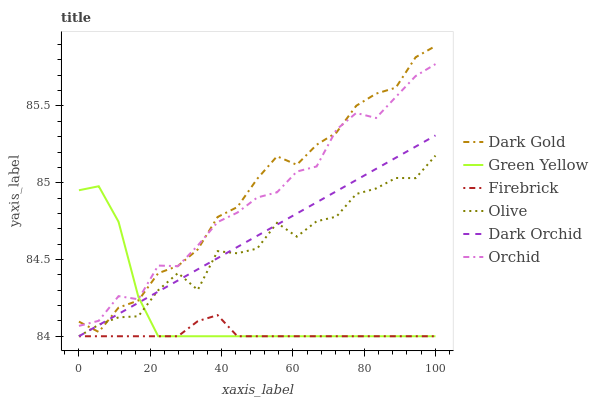Does Firebrick have the minimum area under the curve?
Answer yes or no. Yes. Does Dark Gold have the maximum area under the curve?
Answer yes or no. Yes. Does Dark Orchid have the minimum area under the curve?
Answer yes or no. No. Does Dark Orchid have the maximum area under the curve?
Answer yes or no. No. Is Dark Orchid the smoothest?
Answer yes or no. Yes. Is Olive the roughest?
Answer yes or no. Yes. Is Firebrick the smoothest?
Answer yes or no. No. Is Firebrick the roughest?
Answer yes or no. No. Does Firebrick have the lowest value?
Answer yes or no. Yes. Does Orchid have the lowest value?
Answer yes or no. No. Does Dark Gold have the highest value?
Answer yes or no. Yes. Does Dark Orchid have the highest value?
Answer yes or no. No. Is Dark Orchid less than Orchid?
Answer yes or no. Yes. Is Orchid greater than Olive?
Answer yes or no. Yes. Does Dark Gold intersect Olive?
Answer yes or no. Yes. Is Dark Gold less than Olive?
Answer yes or no. No. Is Dark Gold greater than Olive?
Answer yes or no. No. Does Dark Orchid intersect Orchid?
Answer yes or no. No. 